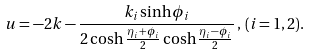Convert formula to latex. <formula><loc_0><loc_0><loc_500><loc_500>u = - 2 k - \frac { k _ { i } \sinh \phi _ { i } } { 2 \cosh \frac { \eta _ { i } + \phi _ { i } } { 2 } \cosh \frac { \eta _ { i } - \phi _ { i } } { 2 } } \, , \, ( i = 1 , 2 ) .</formula> 